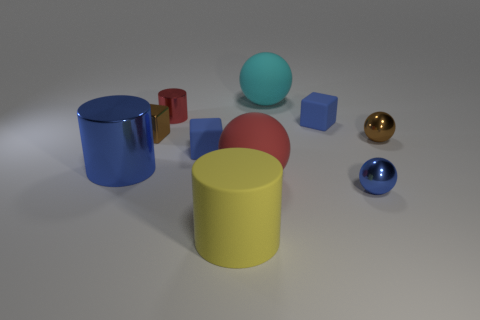The blue rubber thing that is left of the big ball behind the blue metallic thing on the left side of the blue shiny sphere is what shape?
Give a very brief answer. Cube. What number of other things are there of the same shape as the big blue thing?
Ensure brevity in your answer.  2. Is the color of the large metal cylinder the same as the matte block that is behind the small brown metal ball?
Your answer should be compact. Yes. How many cyan matte things are there?
Your answer should be very brief. 1. What number of objects are either tiny red shiny balls or blocks?
Make the answer very short. 3. The shiny sphere that is the same color as the big metal cylinder is what size?
Keep it short and to the point. Small. Are there any tiny red things to the right of the red shiny object?
Make the answer very short. No. Is the number of red metallic cylinders that are behind the blue ball greater than the number of blue rubber cubes left of the red cylinder?
Offer a very short reply. Yes. What size is the red metal thing that is the same shape as the big yellow thing?
Provide a succinct answer. Small. What number of cylinders are either big gray metal things or large yellow things?
Provide a short and direct response. 1. 